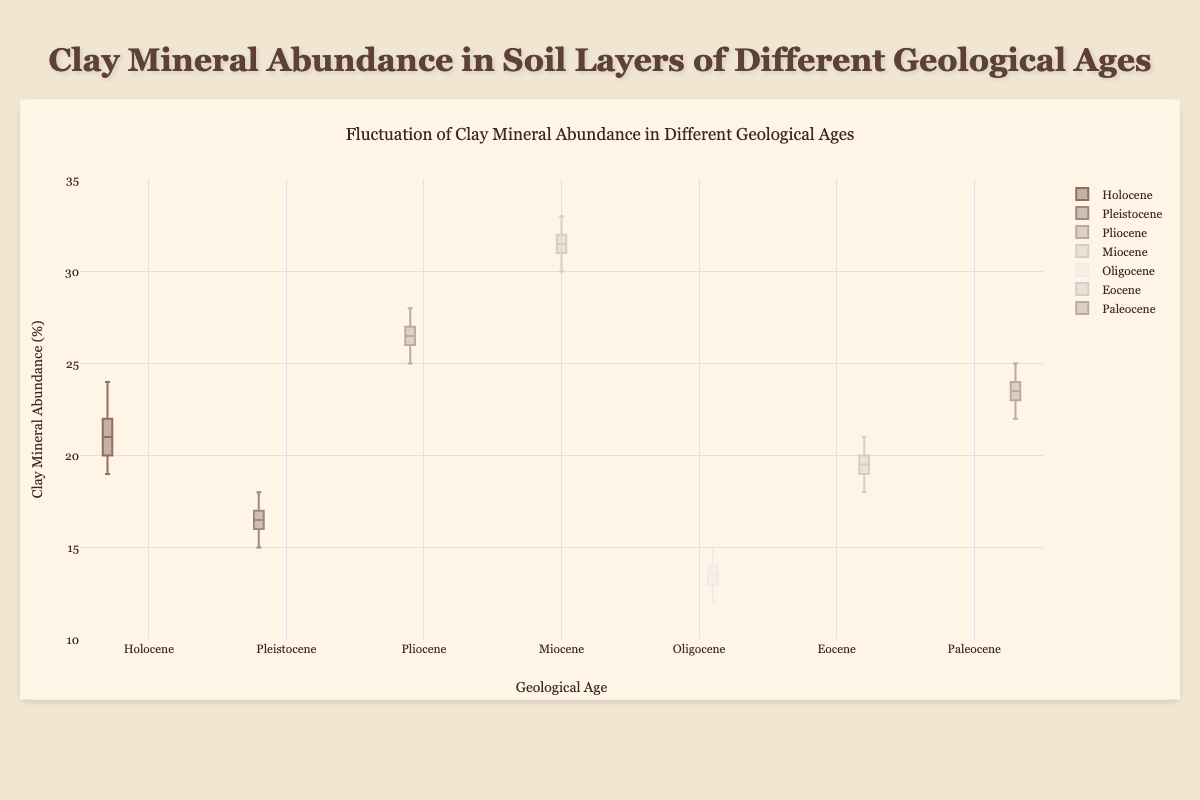What is the title of the figure? The title is usually located at the top of the chart. It provides a summary of the content and purpose of the figure.
Answer: Fluctuation of Clay Mineral Abundance in Different Geological Ages What is the range of the y-axis? The range of the y-axis represents the span of values plotted. This is typically shown on the left side with minimum and maximum values indicated.
Answer: 10 to 35 What geological age has the highest median clay mineral abundance? To find the median value, look for the middle line in the box of each geological age. The median is represented by the line inside the box.
Answer: Miocene Which geological age has the lowest clay mineral abundance? The lowest clay mineral abundance can be determined by identifying the respective minimum whisker of each box plot.
Answer: Oligocene What is the interquartile range (IQR) for the Miocene clay mineral abundance? The IQR is calculated by finding the difference between the third quartile (upper edge of the box) and the first quartile (lower edge of the box) of the Miocene box plot.
Answer: 3 Compare the clay mineral abundance of Holocene and Paleocene. Which one has a wider spread? The spread can be determined by comparing the length of the boxes and the whiskers for both geological ages. The longer the box and whiskers, the wider the spread.
Answer: Paleocene What's the average value of clay mineral abundance in the Pliocene? Sum all the data points in the Pliocene set and divide by the number of data points (which is 10 here). (25 + 27 + 26 + 28 + 27 + 26 + 25 + 26 + 27 + 28) / 10 = 26.5
Answer: 26.5 Which geological age shows no outliers in the clay mineral abundance data? Outliers are typically represented as individual points outside the whiskers in a box plot. Check which box plots do not have these points.
Answer: All of them (no data point falls outside the whiskers) How do the medians of the Pleistocene and Eocene compare? Find the median lines on the Pleistocene and Eocene box plots and compare their positions on the y-axis.
Answer: Median of Eocene is higher than Pleistocene 